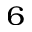Convert formula to latex. <formula><loc_0><loc_0><loc_500><loc_500>_ { 6 }</formula> 